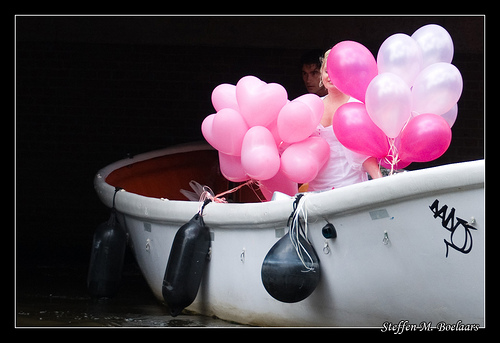<image>
Is the baloon in the boat? Yes. The baloon is contained within or inside the boat, showing a containment relationship. Is the balloon above the ground? Yes. The balloon is positioned above the ground in the vertical space, higher up in the scene. 